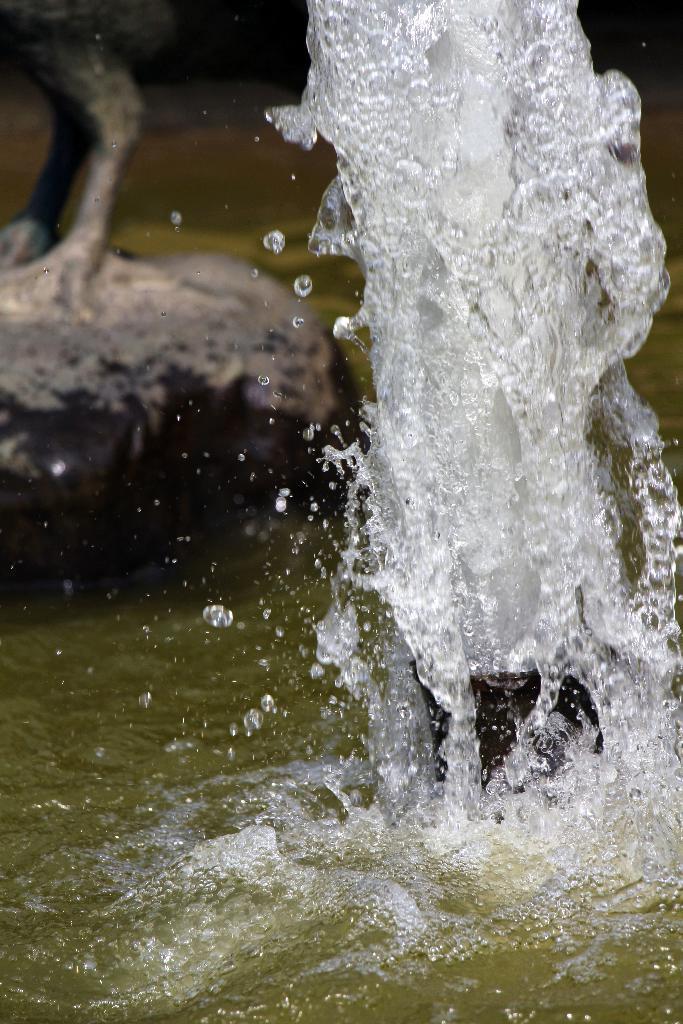Describe this image in one or two sentences. In this image in the foreground there is a pump, and at the bottom there is a lake. And in the background there is a rock and some objects. 